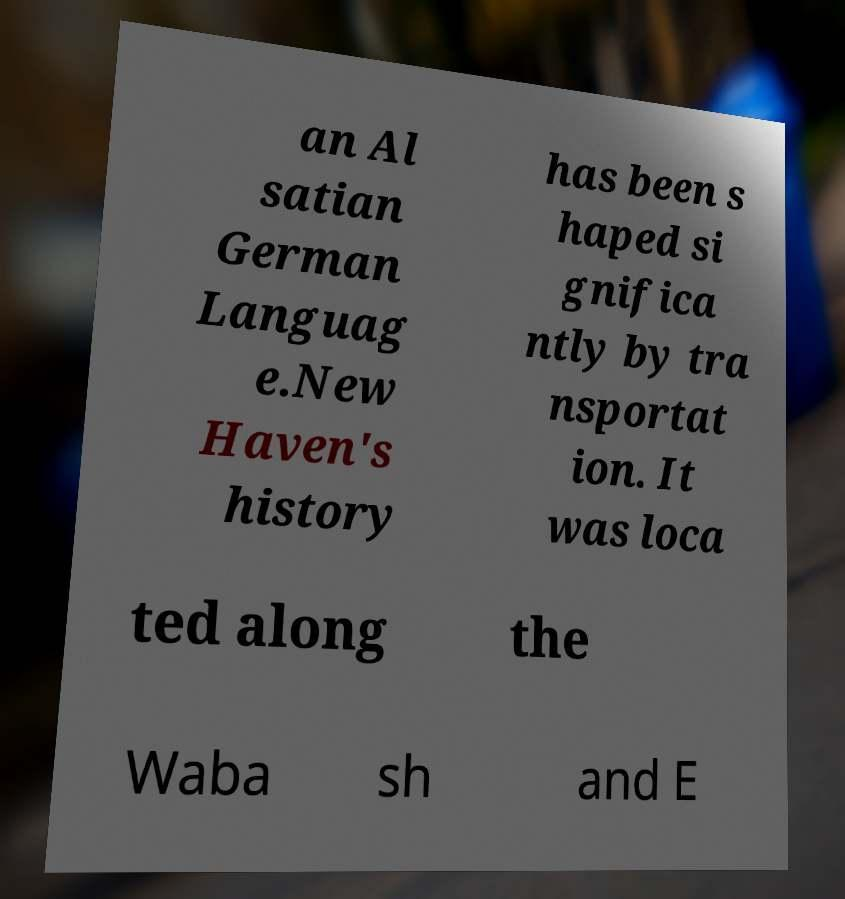What messages or text are displayed in this image? I need them in a readable, typed format. an Al satian German Languag e.New Haven's history has been s haped si gnifica ntly by tra nsportat ion. It was loca ted along the Waba sh and E 